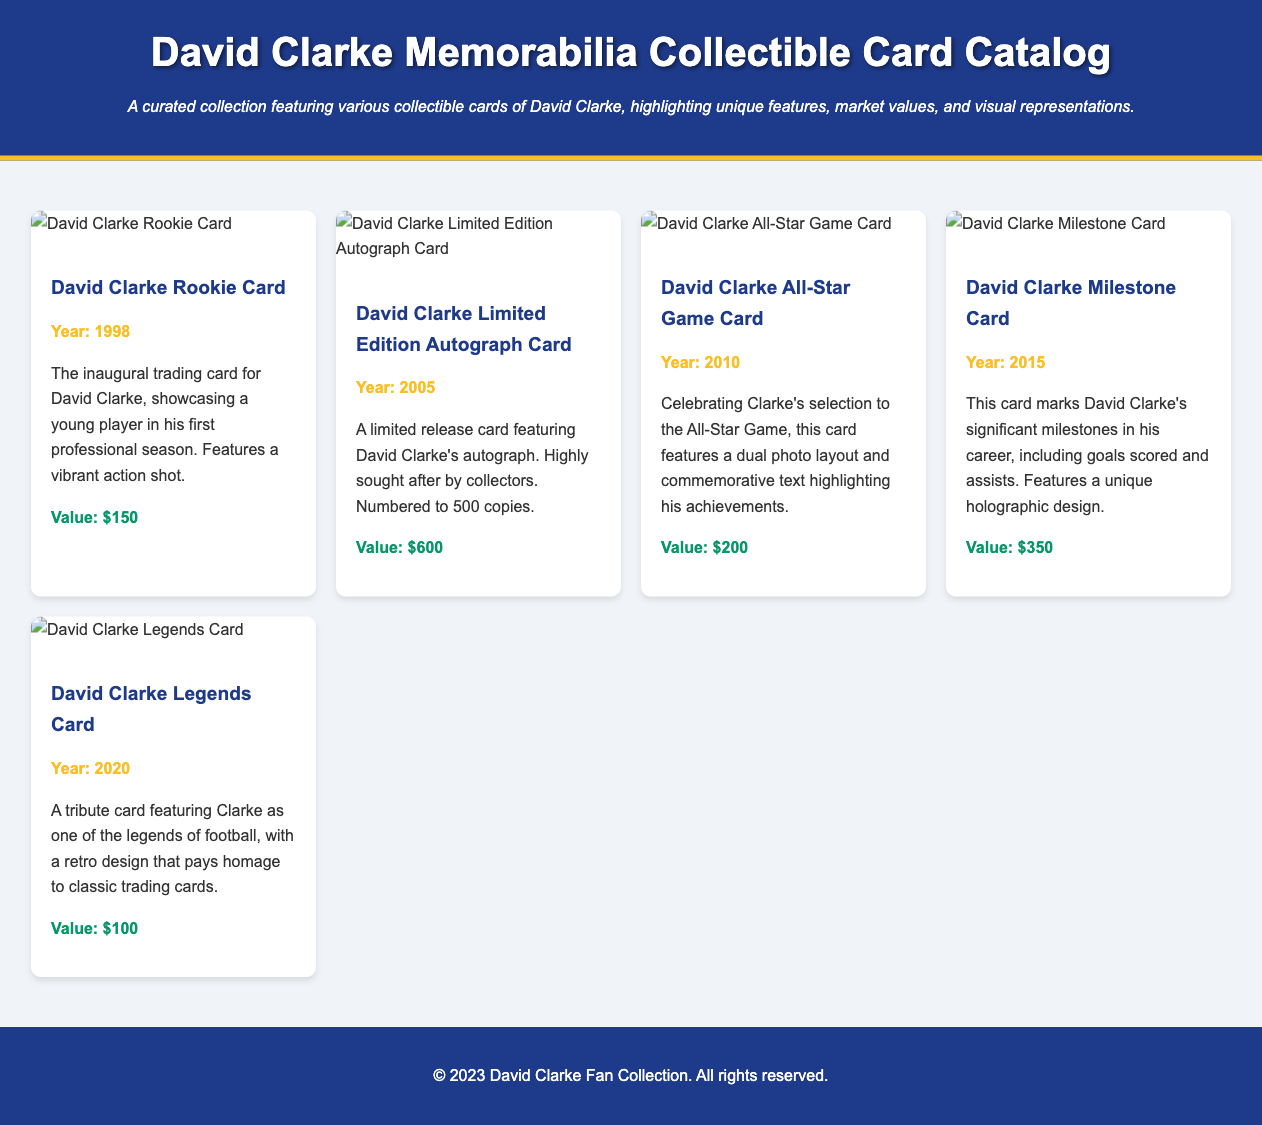What is the title of the catalog? The title is prominently displayed in the header of the document.
Answer: David Clarke Memorabilia Collectible Card Catalog How many cards are featured in the catalog? There are five distinct collectible cards showcased in the card grid.
Answer: 5 What year was the David Clarke Rookie Card released? The year of the Rookie Card is provided under the card title in the document.
Answer: 1998 What is the value of the David Clarke Limited Edition Autograph Card? The value is stated directly beneath the card description.
Answer: $600 Which card commemorates David Clarke's selection to the All-Star Game? The card title and description provide information on this specific card.
Answer: David Clarke All-Star Game Card Which card has a holographic design? The description for this card indicates the unique design features it possesses.
Answer: David Clarke Milestone Card What is the lowest value card in the collection? The values of the cards are listed, with the lowest value mentioned in the description for one of the cards.
Answer: $100 What year was the Legends Card created? The year of creation is indicated just below the card title in the document.
Answer: 2020 What feature distinguishes the Limited Edition Autograph Card? The description specifically mentions distinguishing features of this card.
Answer: Autograph 